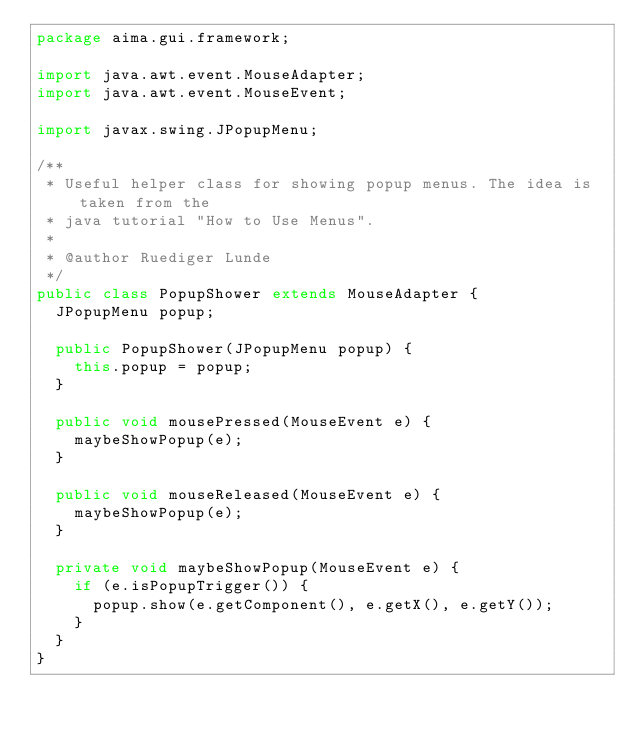Convert code to text. <code><loc_0><loc_0><loc_500><loc_500><_Java_>package aima.gui.framework;

import java.awt.event.MouseAdapter;
import java.awt.event.MouseEvent;

import javax.swing.JPopupMenu;

/**
 * Useful helper class for showing popup menus. The idea is taken from the
 * java tutorial "How to Use Menus".
 * 
 * @author Ruediger Lunde
 */
public class PopupShower extends MouseAdapter {
	JPopupMenu popup;

	public PopupShower(JPopupMenu popup) {
		this.popup = popup;
	}

	public void mousePressed(MouseEvent e) {
		maybeShowPopup(e);
	}

	public void mouseReleased(MouseEvent e) {
		maybeShowPopup(e);
	}

	private void maybeShowPopup(MouseEvent e) {
		if (e.isPopupTrigger()) {
			popup.show(e.getComponent(), e.getX(), e.getY());
		}
	}
}
</code> 